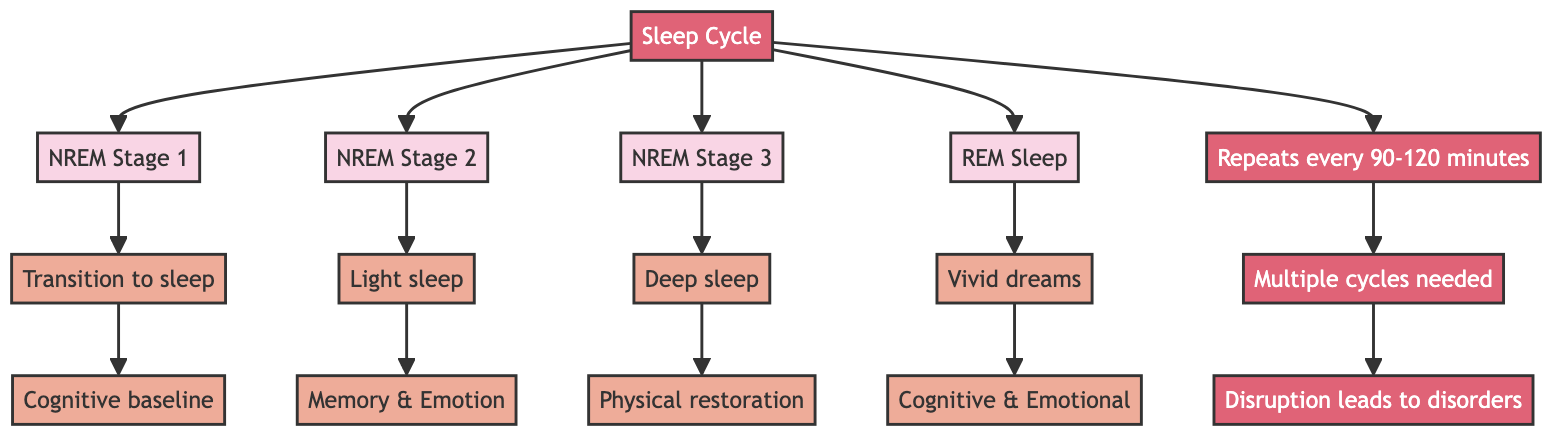What is the starting point of the flowchart? The flowchart starts with "Sleep Cycle" which is the main node that connects all the different sleep stages.
Answer: Sleep Cycle How many main sleep stages are depicted in the diagram? The diagram shows four main sleep stages: NREM Stage 1, NREM Stage 2, NREM Stage 3, and REM Sleep.
Answer: Four What does NREM Stage 2 primarily impact? NREM Stage 2 is important for memory consolidation and emotional regulation, which directly connects to the impact noted for this stage.
Answer: Memory & Emotion What happens during NREM Stage 3? NREM Stage 3 is a deep sleep stage also known as slow-wave sleep, which is critical for physical restoration.
Answer: Physical restoration How often does a sleep cycle repeat? According to the flowchart, a sleep cycle repeats every 90-120 minutes, which is a direct statement from the flowchart.
Answer: 90-120 minutes What does the disruption of sleep cycles lead to? The flowchart indicates that disruption leads to sleep disorders, which is the consequence of not maintaining multiple cycles effectively.
Answer: Sleep disorders Which stage involves vivid dreams? REM Sleep is characterized by rapid eye movement and vivid dreams, as shown in the flowchart.
Answer: REM Sleep What is the relationship between NREM Stage 1 and cognitive function? NREM Stage 1 sets the cognitive baseline for restful sleep, and a lack of this stage can lead to cognitive impairments, demonstrating a key relationship in the flowchart.
Answer: Cognitive baseline How do the stages NREM Stage 2 and NREM Stage 3 differ in their impacts? NREM Stage 2 impacts memory consolidation and emotional regulation, whereas NREM Stage 3 is critical for physical restoration, showcasing different psychological functions.
Answer: Different psychological functions What connects the stages of sleep to mental health? The entire structure of the flowchart links the stages through the "Sleep Cycle" to the impacts on mental health, indicating the importance of all sleep stages in maintaining mental health.
Answer: Sleep Cycle 